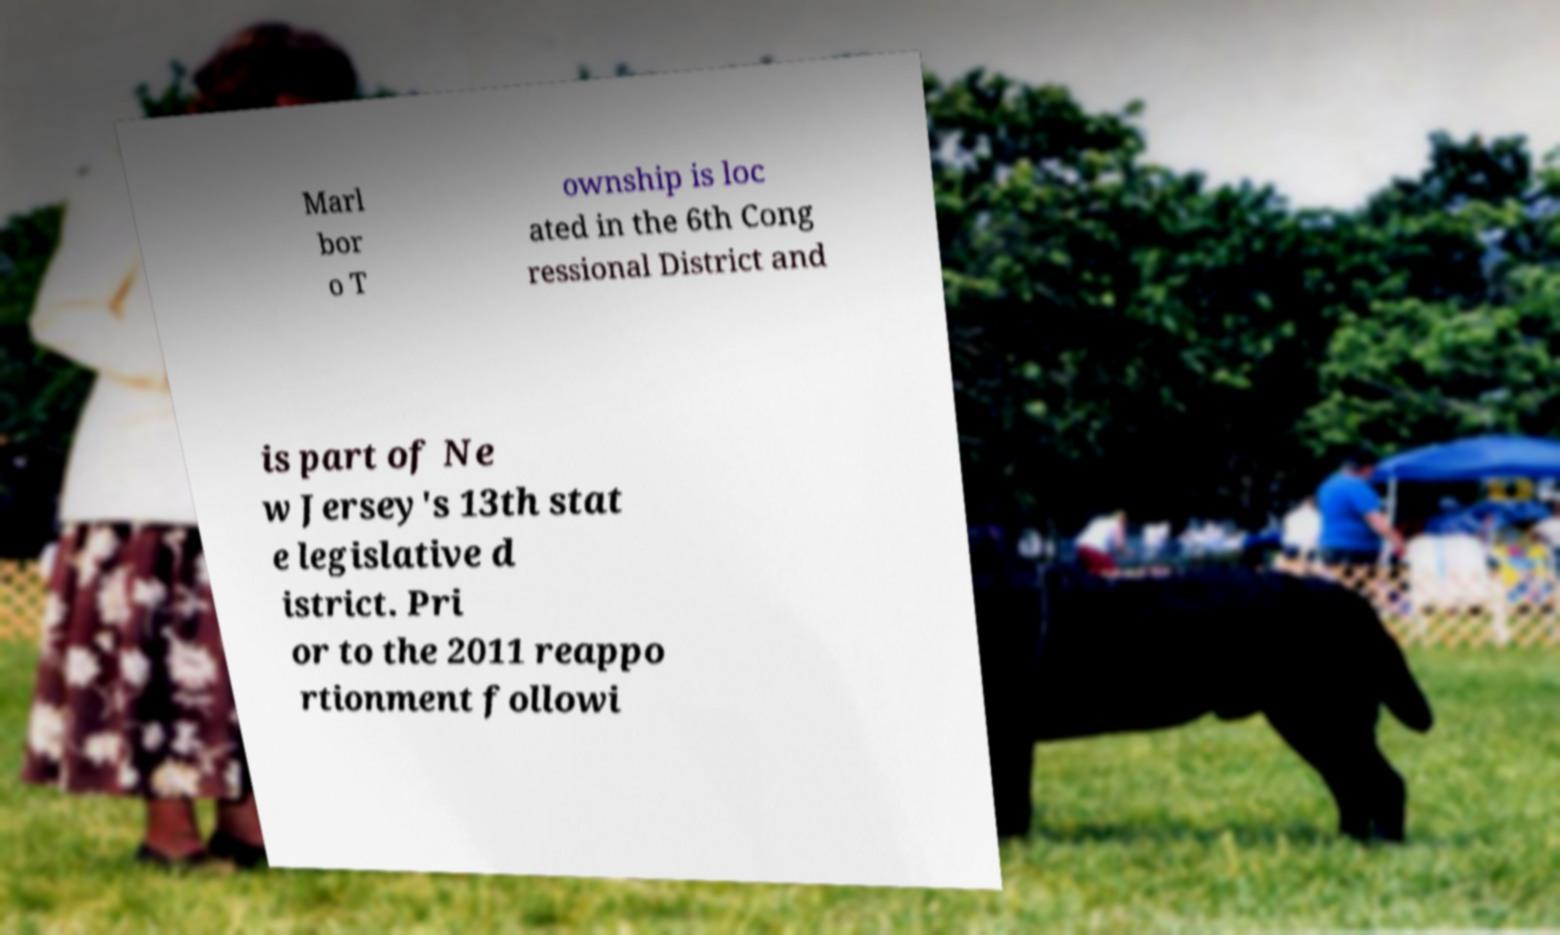Please read and relay the text visible in this image. What does it say? Marl bor o T ownship is loc ated in the 6th Cong ressional District and is part of Ne w Jersey's 13th stat e legislative d istrict. Pri or to the 2011 reappo rtionment followi 